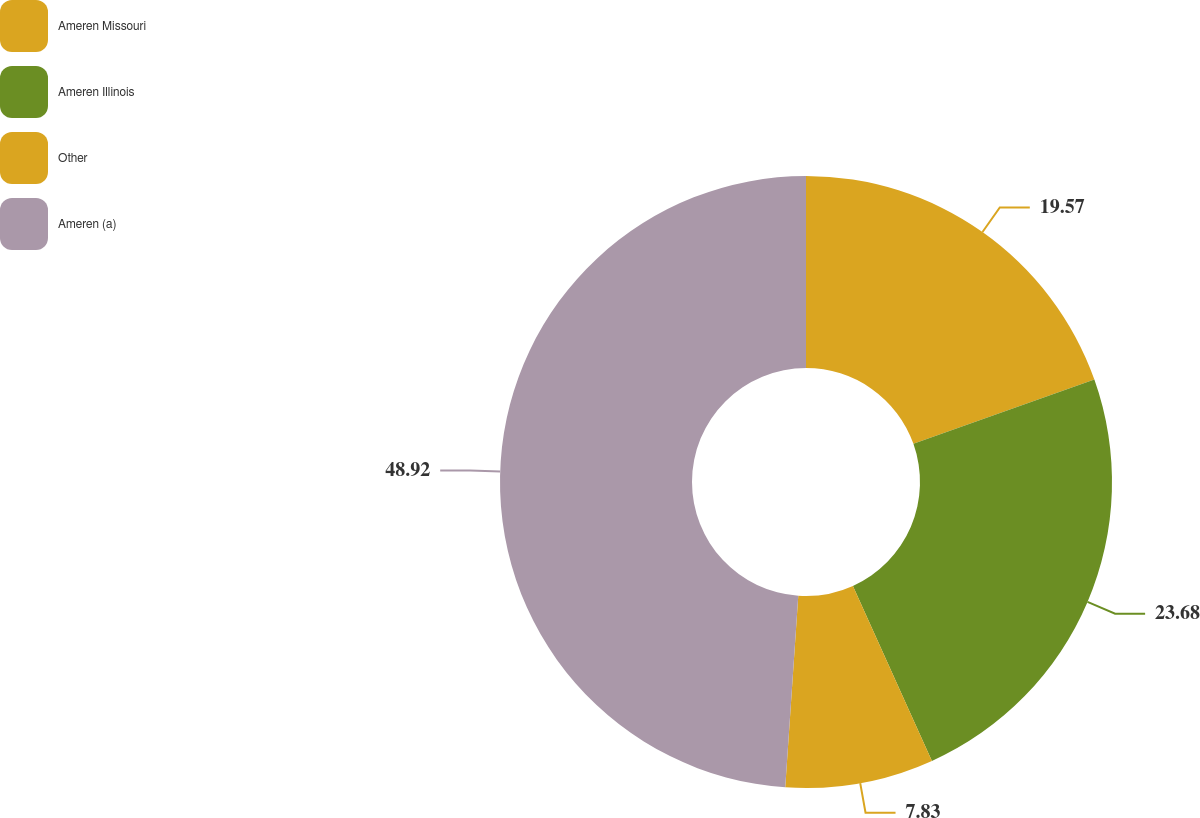Convert chart. <chart><loc_0><loc_0><loc_500><loc_500><pie_chart><fcel>Ameren Missouri<fcel>Ameren Illinois<fcel>Other<fcel>Ameren (a)<nl><fcel>19.57%<fcel>23.68%<fcel>7.83%<fcel>48.92%<nl></chart> 